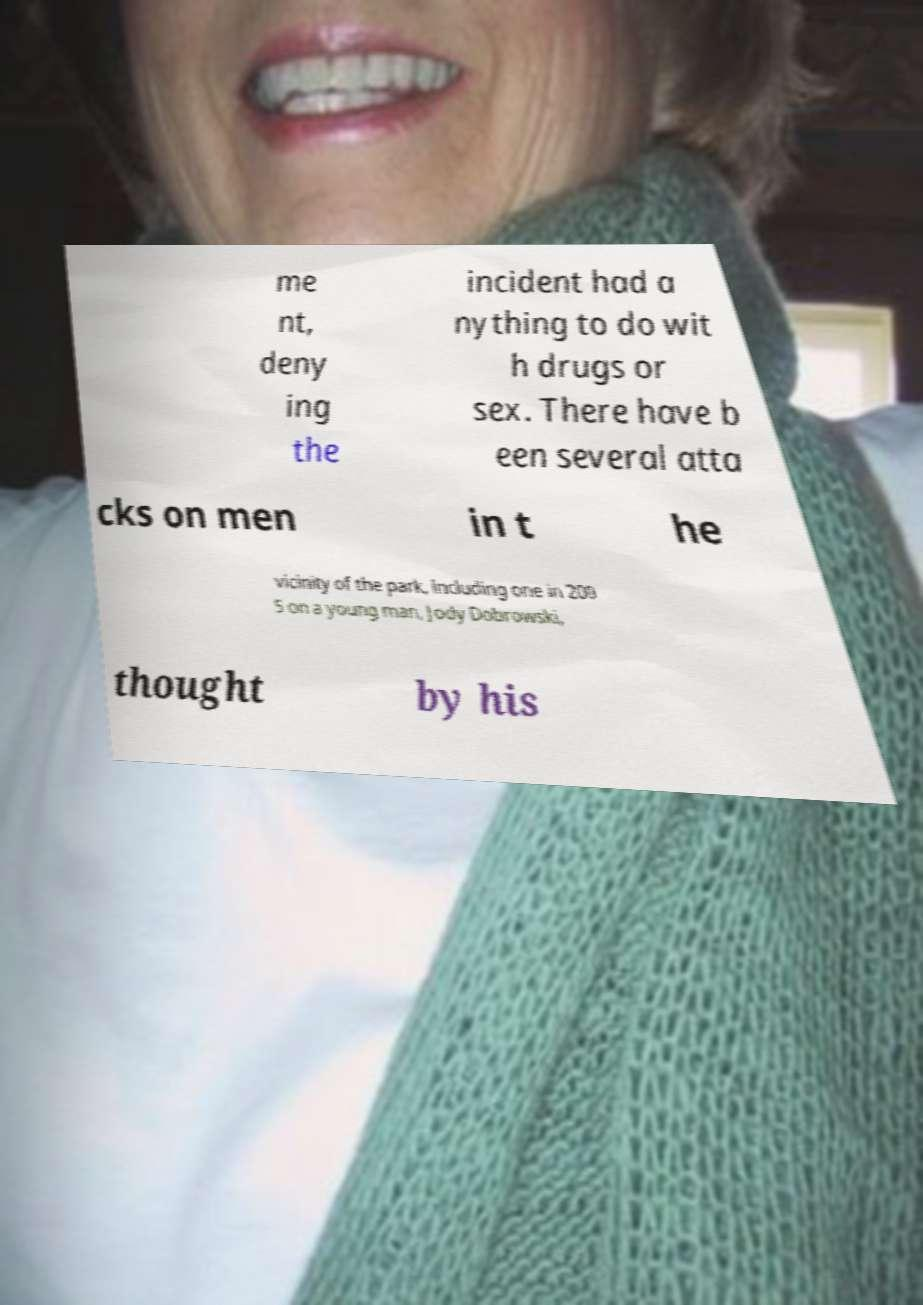Please read and relay the text visible in this image. What does it say? me nt, deny ing the incident had a nything to do wit h drugs or sex. There have b een several atta cks on men in t he vicinity of the park, including one in 200 5 on a young man, Jody Dobrowski, thought by his 